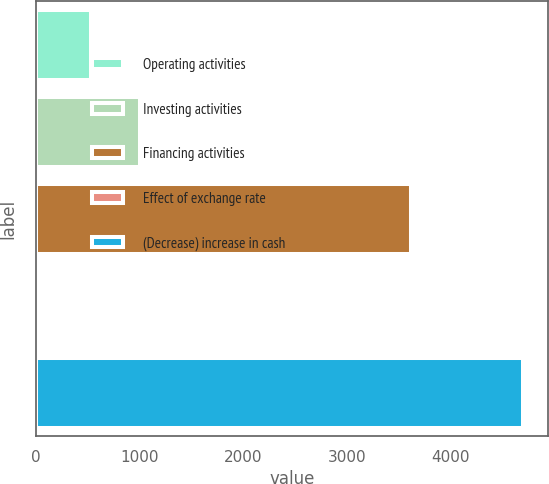Convert chart. <chart><loc_0><loc_0><loc_500><loc_500><bar_chart><fcel>Operating activities<fcel>Investing activities<fcel>Financing activities<fcel>Effect of exchange rate<fcel>(Decrease) increase in cash<nl><fcel>531<fcel>1000.9<fcel>3624<fcel>5<fcel>4704<nl></chart> 